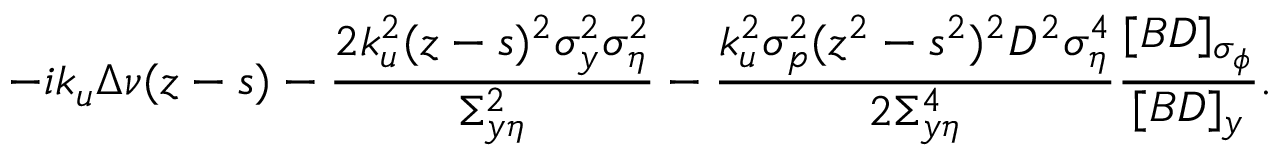Convert formula to latex. <formula><loc_0><loc_0><loc_500><loc_500>- i k _ { u } \Delta \nu ( z - s ) - \frac { 2 k _ { u } ^ { 2 } ( z - s ) ^ { 2 } \sigma _ { y } ^ { 2 } \sigma _ { \eta } ^ { 2 } } { \Sigma _ { y \eta } ^ { 2 } } - \frac { k _ { u } ^ { 2 } \sigma _ { p } ^ { 2 } ( z ^ { 2 } - s ^ { 2 } ) ^ { 2 } D ^ { 2 } \sigma _ { \eta } ^ { 4 } } { 2 \Sigma _ { y \eta } ^ { 4 } } \frac { [ B D ] _ { \sigma _ { \phi } } } { [ B D ] _ { y } } .</formula> 